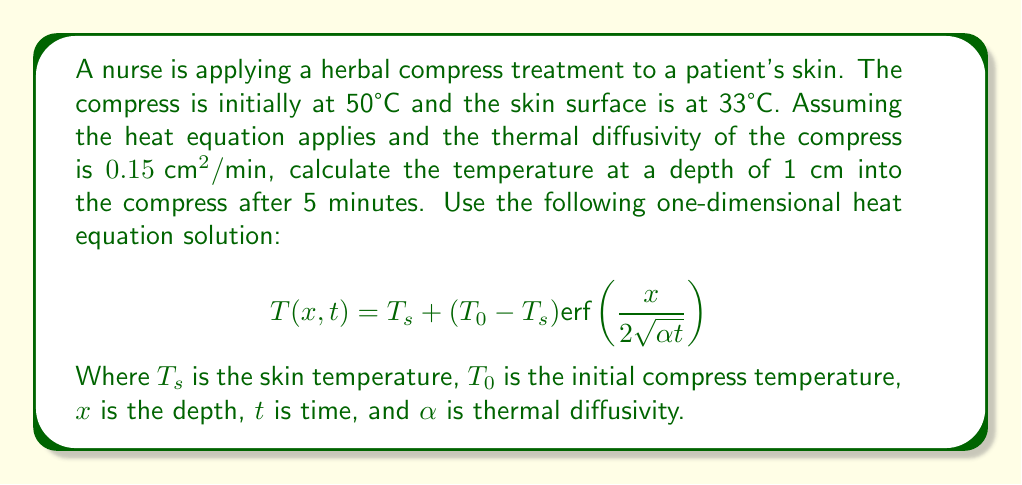Show me your answer to this math problem. To solve this problem, we'll follow these steps:

1) Identify the given values:
   $T_s = 33°C$ (skin temperature)
   $T_0 = 50°C$ (initial compress temperature)
   $x = 1 \text{ cm}$ (depth)
   $t = 5 \text{ min}$ (time)
   $\alpha = 0.15 \text{ cm}^2/\text{min}$ (thermal diffusivity)

2) Substitute these values into the equation:
   $$T(1,5) = 33 + (50 - 33) \text{erf}\left(\frac{1}{2\sqrt{0.15 \cdot 5}}\right)$$

3) Simplify inside the erf function:
   $$T(1,5) = 33 + 17 \text{erf}\left(\frac{1}{2\sqrt{0.75}}\right)$$

4) Calculate $\sqrt{0.75} \approx 0.866$:
   $$T(1,5) = 33 + 17 \text{erf}\left(\frac{1}{1.732}\right)$$

5) Calculate $\frac{1}{1.732} \approx 0.577$

6) Look up or calculate erf(0.577) ≈ 0.5961

7) Finish the calculation:
   $$T(1,5) = 33 + 17 \cdot 0.5961 = 33 + 10.13 = 43.13°C$$

Therefore, the temperature at a depth of 1 cm into the compress after 5 minutes is approximately 43.13°C.
Answer: 43.13°C 